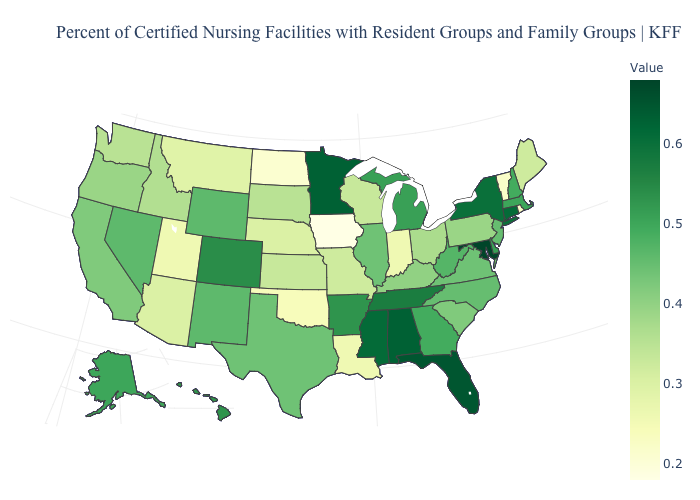Does Maryland have the highest value in the USA?
Write a very short answer. Yes. Which states have the lowest value in the MidWest?
Quick response, please. Iowa. Among the states that border Virginia , does Maryland have the highest value?
Answer briefly. Yes. 